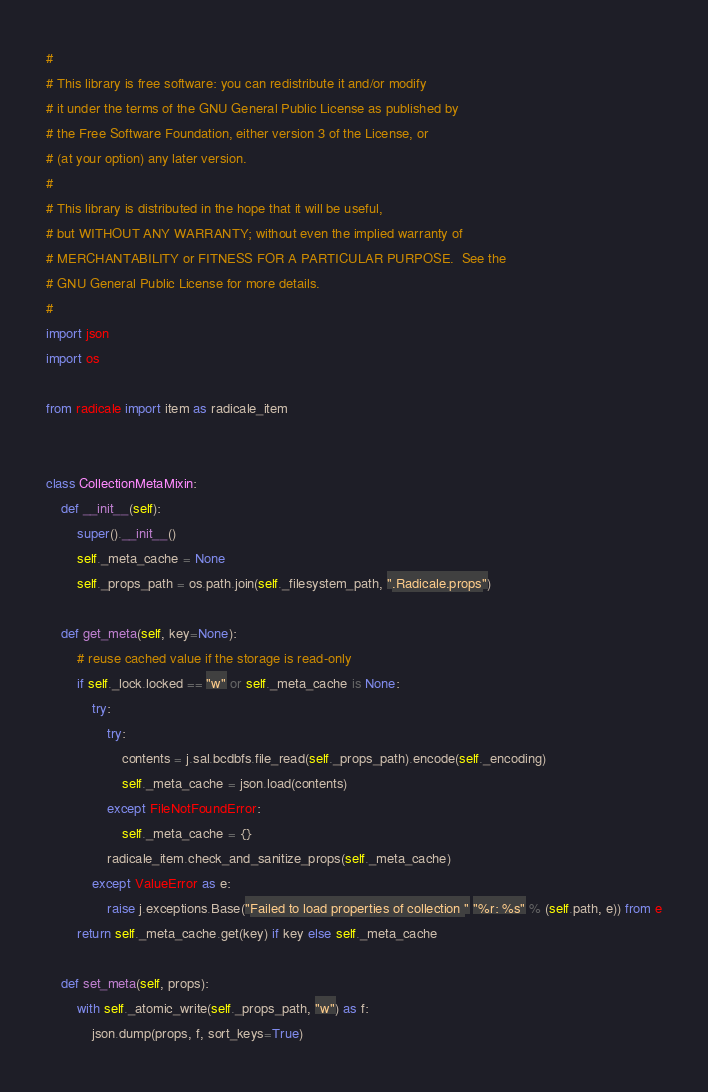Convert code to text. <code><loc_0><loc_0><loc_500><loc_500><_Python_>#
# This library is free software: you can redistribute it and/or modify
# it under the terms of the GNU General Public License as published by
# the Free Software Foundation, either version 3 of the License, or
# (at your option) any later version.
#
# This library is distributed in the hope that it will be useful,
# but WITHOUT ANY WARRANTY; without even the implied warranty of
# MERCHANTABILITY or FITNESS FOR A PARTICULAR PURPOSE.  See the
# GNU General Public License for more details.
#
import json
import os

from radicale import item as radicale_item


class CollectionMetaMixin:
    def __init__(self):
        super().__init__()
        self._meta_cache = None
        self._props_path = os.path.join(self._filesystem_path, ".Radicale.props")

    def get_meta(self, key=None):
        # reuse cached value if the storage is read-only
        if self._lock.locked == "w" or self._meta_cache is None:
            try:
                try:
                    contents = j.sal.bcdbfs.file_read(self._props_path).encode(self._encoding)
                    self._meta_cache = json.load(contents)
                except FileNotFoundError:
                    self._meta_cache = {}
                radicale_item.check_and_sanitize_props(self._meta_cache)
            except ValueError as e:
                raise j.exceptions.Base("Failed to load properties of collection " "%r: %s" % (self.path, e)) from e
        return self._meta_cache.get(key) if key else self._meta_cache

    def set_meta(self, props):
        with self._atomic_write(self._props_path, "w") as f:
            json.dump(props, f, sort_keys=True)
</code> 